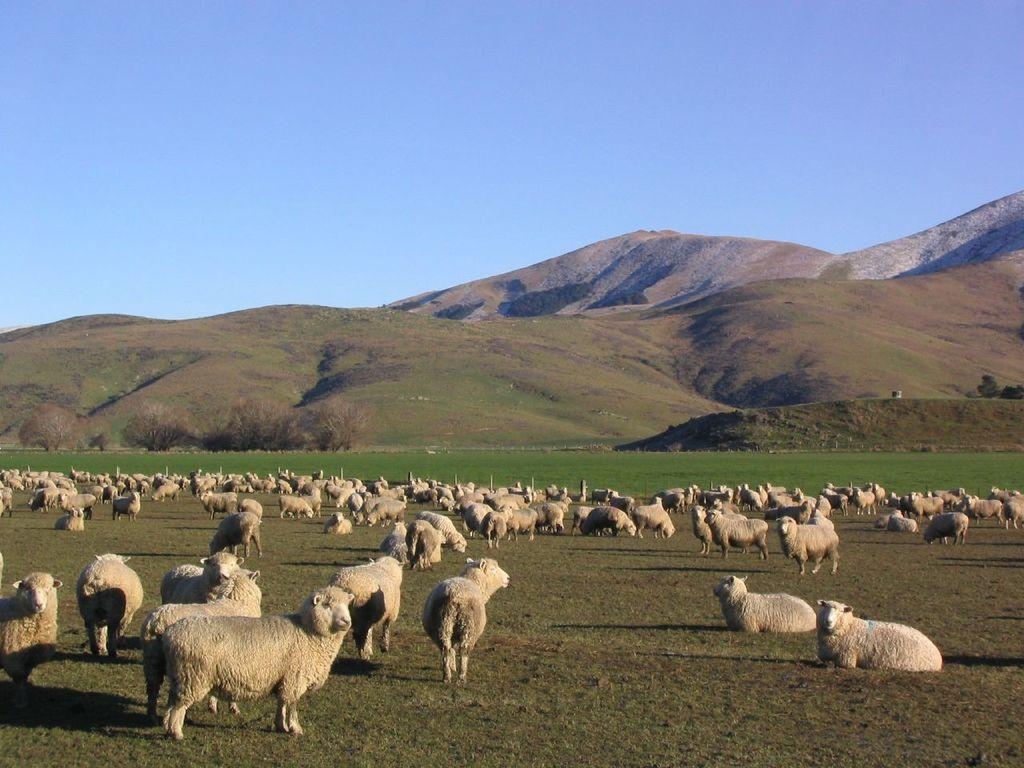What type of animals can be seen in the image? There is a herd of sheep in the image. What is on the ground in the image? There is grass on the ground in the image. What geographical feature is visible in the image? There is a hill visible in the image. What type of vegetation is present in the image? There are trees in the image. What color is the sky in the image? The sky is blue in the image. What language are the sheep speaking in the image? Sheep do not speak a language, so this cannot be determined from the image. How many corks can be seen in the image? There are no corks present in the image. 